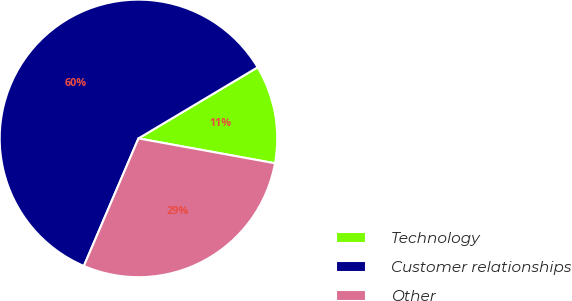<chart> <loc_0><loc_0><loc_500><loc_500><pie_chart><fcel>Technology<fcel>Customer relationships<fcel>Other<nl><fcel>11.43%<fcel>60.0%<fcel>28.57%<nl></chart> 